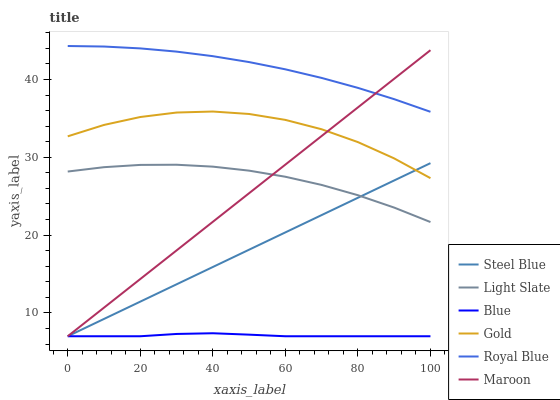Does Blue have the minimum area under the curve?
Answer yes or no. Yes. Does Royal Blue have the maximum area under the curve?
Answer yes or no. Yes. Does Gold have the minimum area under the curve?
Answer yes or no. No. Does Gold have the maximum area under the curve?
Answer yes or no. No. Is Steel Blue the smoothest?
Answer yes or no. Yes. Is Gold the roughest?
Answer yes or no. Yes. Is Light Slate the smoothest?
Answer yes or no. No. Is Light Slate the roughest?
Answer yes or no. No. Does Blue have the lowest value?
Answer yes or no. Yes. Does Gold have the lowest value?
Answer yes or no. No. Does Royal Blue have the highest value?
Answer yes or no. Yes. Does Gold have the highest value?
Answer yes or no. No. Is Blue less than Gold?
Answer yes or no. Yes. Is Light Slate greater than Blue?
Answer yes or no. Yes. Does Gold intersect Steel Blue?
Answer yes or no. Yes. Is Gold less than Steel Blue?
Answer yes or no. No. Is Gold greater than Steel Blue?
Answer yes or no. No. Does Blue intersect Gold?
Answer yes or no. No. 